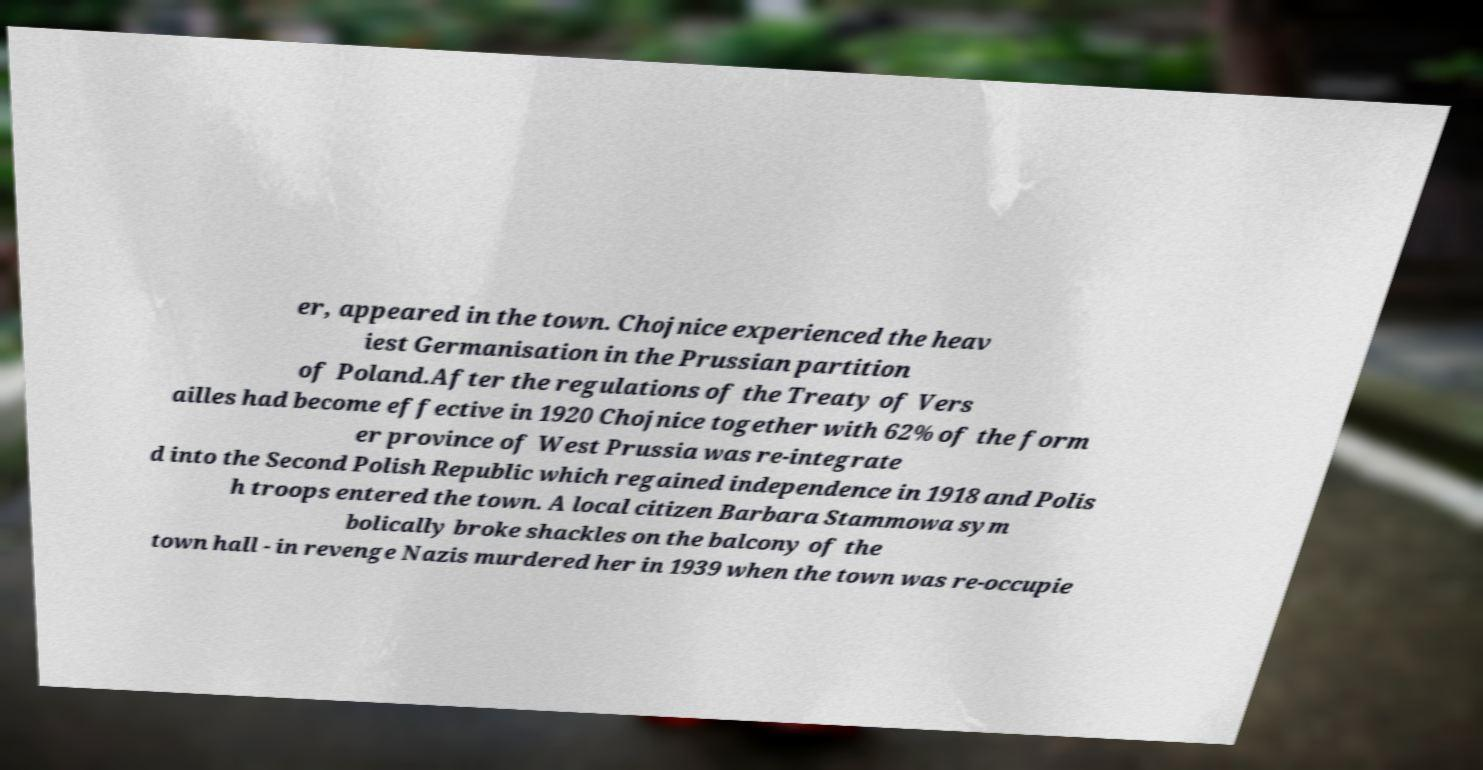Could you extract and type out the text from this image? er, appeared in the town. Chojnice experienced the heav iest Germanisation in the Prussian partition of Poland.After the regulations of the Treaty of Vers ailles had become effective in 1920 Chojnice together with 62% of the form er province of West Prussia was re-integrate d into the Second Polish Republic which regained independence in 1918 and Polis h troops entered the town. A local citizen Barbara Stammowa sym bolically broke shackles on the balcony of the town hall - in revenge Nazis murdered her in 1939 when the town was re-occupie 